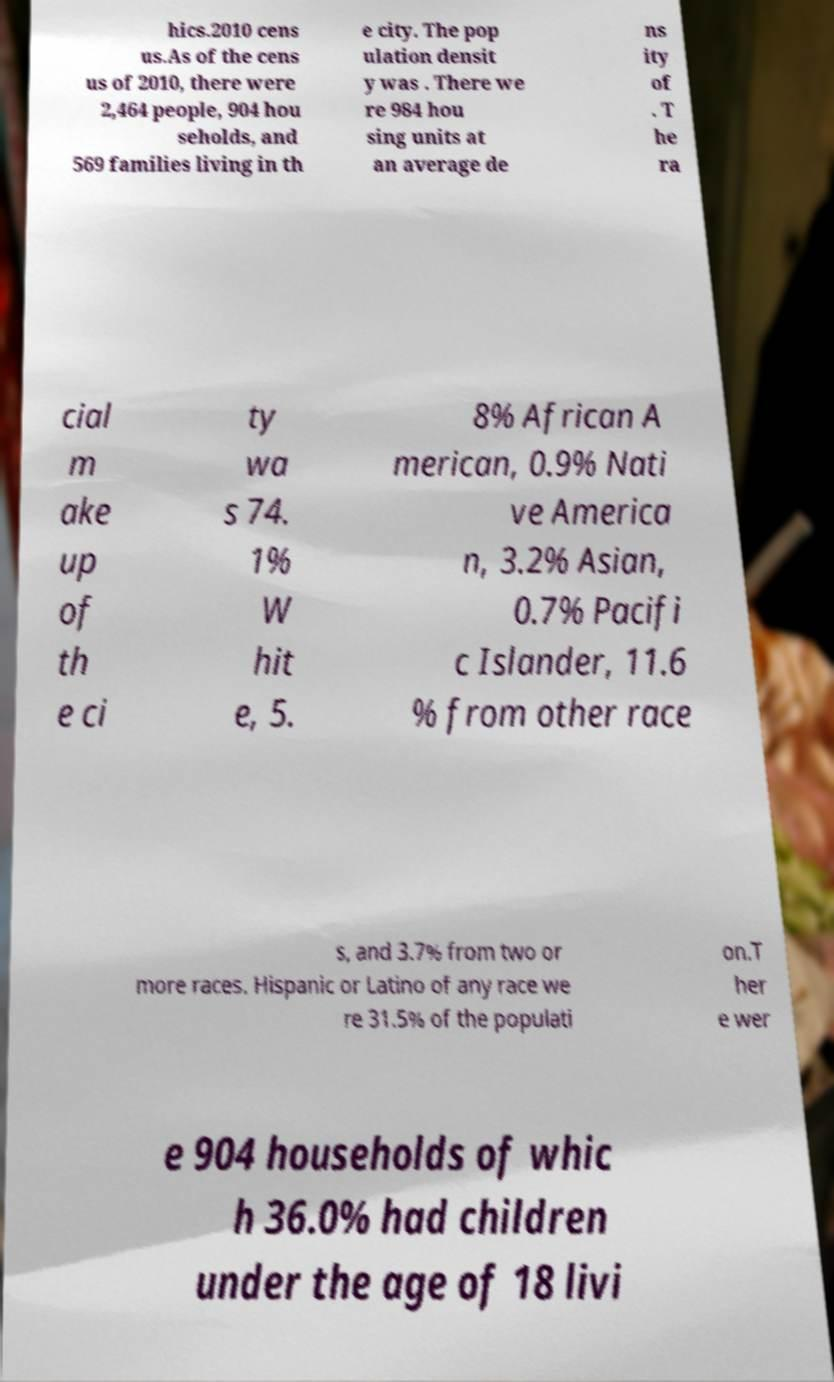I need the written content from this picture converted into text. Can you do that? hics.2010 cens us.As of the cens us of 2010, there were 2,464 people, 904 hou seholds, and 569 families living in th e city. The pop ulation densit y was . There we re 984 hou sing units at an average de ns ity of . T he ra cial m ake up of th e ci ty wa s 74. 1% W hit e, 5. 8% African A merican, 0.9% Nati ve America n, 3.2% Asian, 0.7% Pacifi c Islander, 11.6 % from other race s, and 3.7% from two or more races. Hispanic or Latino of any race we re 31.5% of the populati on.T her e wer e 904 households of whic h 36.0% had children under the age of 18 livi 